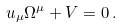<formula> <loc_0><loc_0><loc_500><loc_500>u _ { \mu } \Omega ^ { \mu } + V = 0 \, .</formula> 